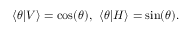<formula> <loc_0><loc_0><loc_500><loc_500>\langle \theta | V \rangle = \cos ( \theta ) , \, \langle \theta | H \rangle = \sin ( \theta ) .</formula> 